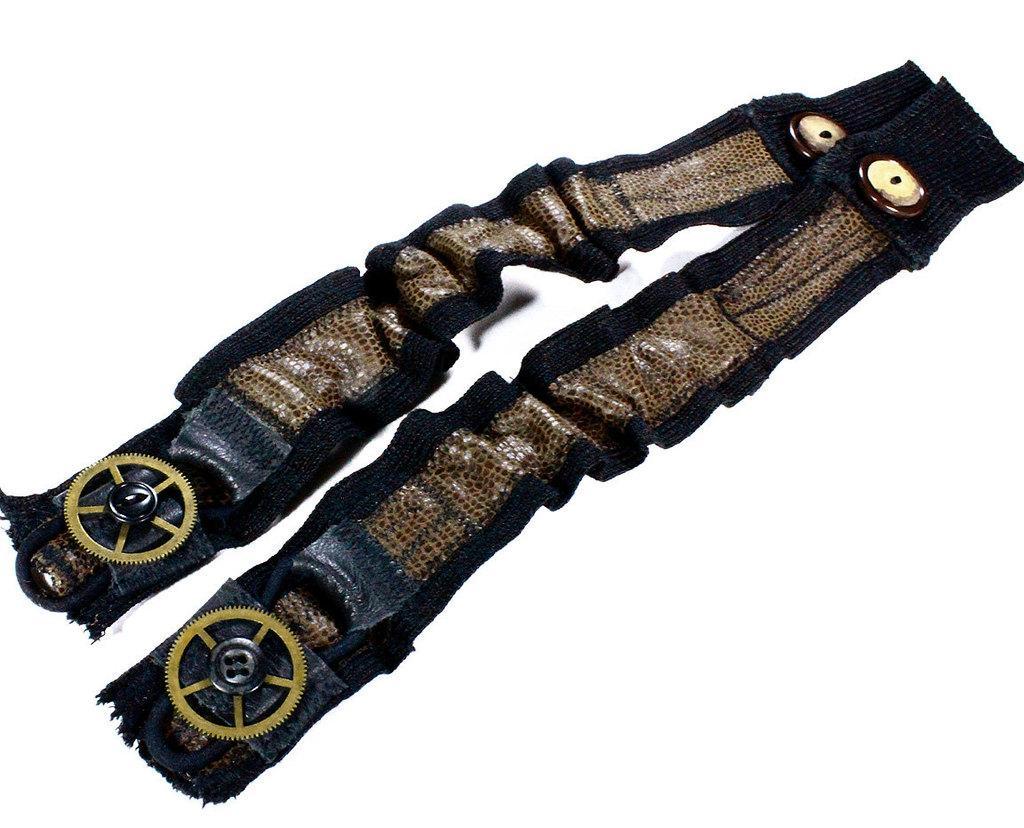Could you give a brief overview of what you see in this image? In this image we can see leather straps. On the leather straps there are buttons, wheels and other objects. The background of the image is white. 